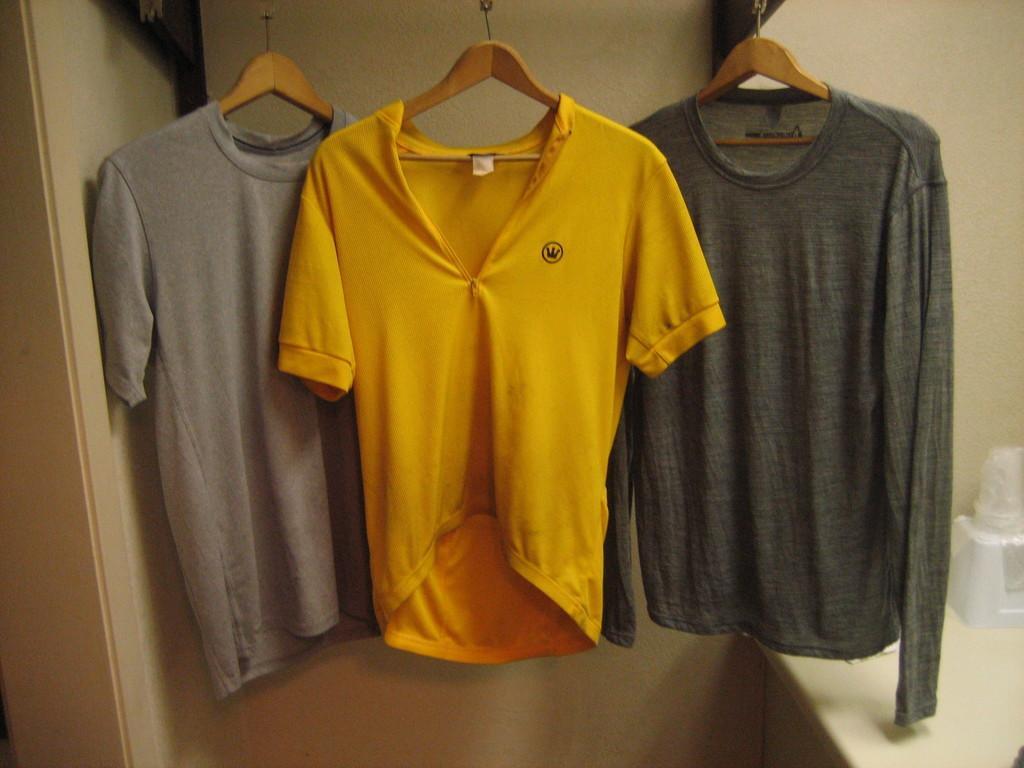Please provide a concise description of this image. In the center of the image, we can see clothes hanging to the hangers and in the background, there is a wall and we can an object on the stand. 